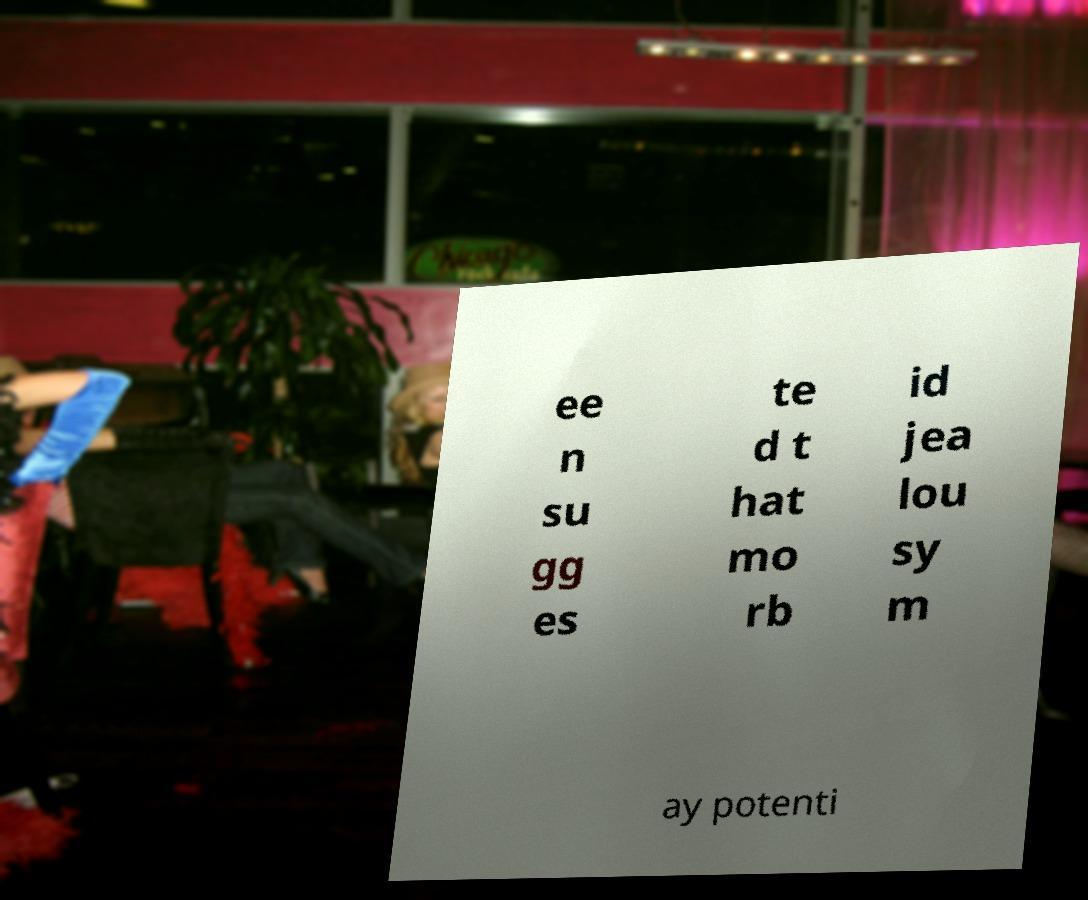Could you extract and type out the text from this image? ee n su gg es te d t hat mo rb id jea lou sy m ay potenti 